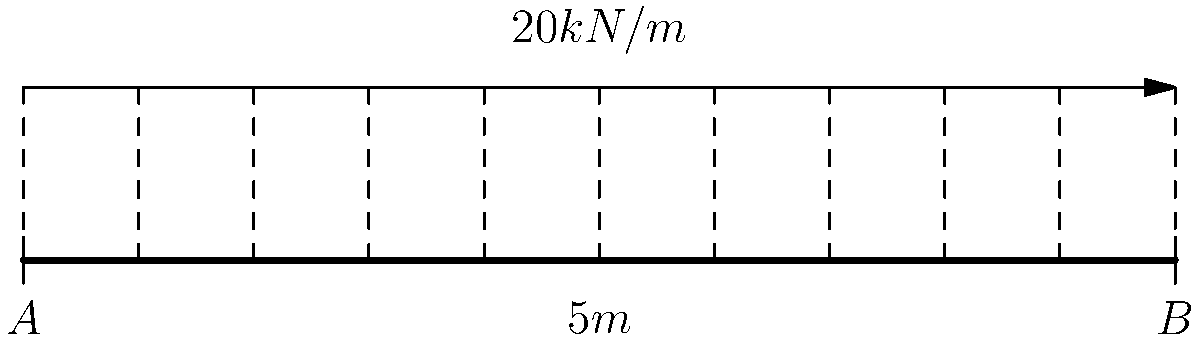Consider a simply supported bridge beam of length 10m subjected to a uniformly distributed load of 20 kN/m along its entire span. Using your expertise in biomechanics and load analysis, determine the maximum shear force and bending moment experienced by the bridge. How might these forces relate to potential injury risks in load-bearing joints of athletes? Let's approach this step-by-step:

1) First, calculate the total load on the beam:
   Total load = $20 \text{ kN/m} \times 10 \text{ m} = 200 \text{ kN}$

2) For a simply supported beam, each support bears half of the total load:
   Reaction at A = Reaction at B = $200 \text{ kN} / 2 = 100 \text{ kN}$

3) The shear force diagram is linear, starting at 100 kN at A, decreasing to 0 at the midspan, and then to -100 kN at B.
   Maximum shear force = $100 \text{ kN}$ (absolute value)

4) The bending moment diagram is parabolic. The maximum occurs at the midspan:
   $M_{max} = \frac{wL^2}{8} = \frac{20 \text{ kN/m} \times (10 \text{ m})^2}{8} = 250 \text{ kN}\cdot\text{m}$

5) Relating to biomechanics:
   - Shear forces in joints can lead to ligament and meniscus injuries, especially in knees and ankles.
   - Bending moments relate to compressive and tensile forces in bones and muscles, which can lead to stress fractures or muscle strains if excessive.
   - The distribution of forces across a structure (like the bridge or a human body) is crucial for preventing localized stress concentrations that could lead to failure or injury.
Answer: Maximum shear force: 100 kN; Maximum bending moment: 250 kN·m. These forces relate to potential ligament, meniscus, bone, and muscle injuries in athletes due to shear and bending stresses in joints and limbs. 